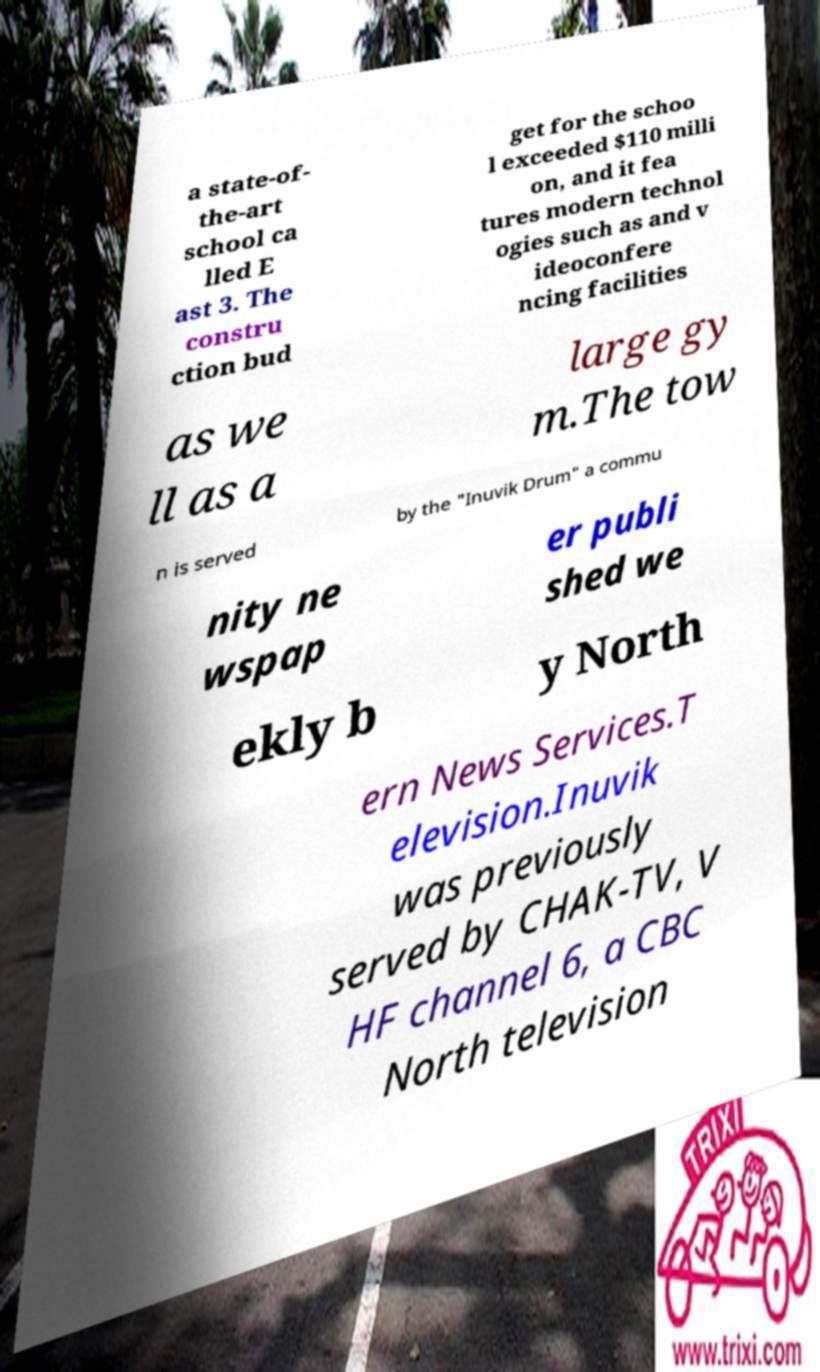Please read and relay the text visible in this image. What does it say? a state-of- the-art school ca lled E ast 3. The constru ction bud get for the schoo l exceeded $110 milli on, and it fea tures modern technol ogies such as and v ideoconfere ncing facilities as we ll as a large gy m.The tow n is served by the "Inuvik Drum" a commu nity ne wspap er publi shed we ekly b y North ern News Services.T elevision.Inuvik was previously served by CHAK-TV, V HF channel 6, a CBC North television 